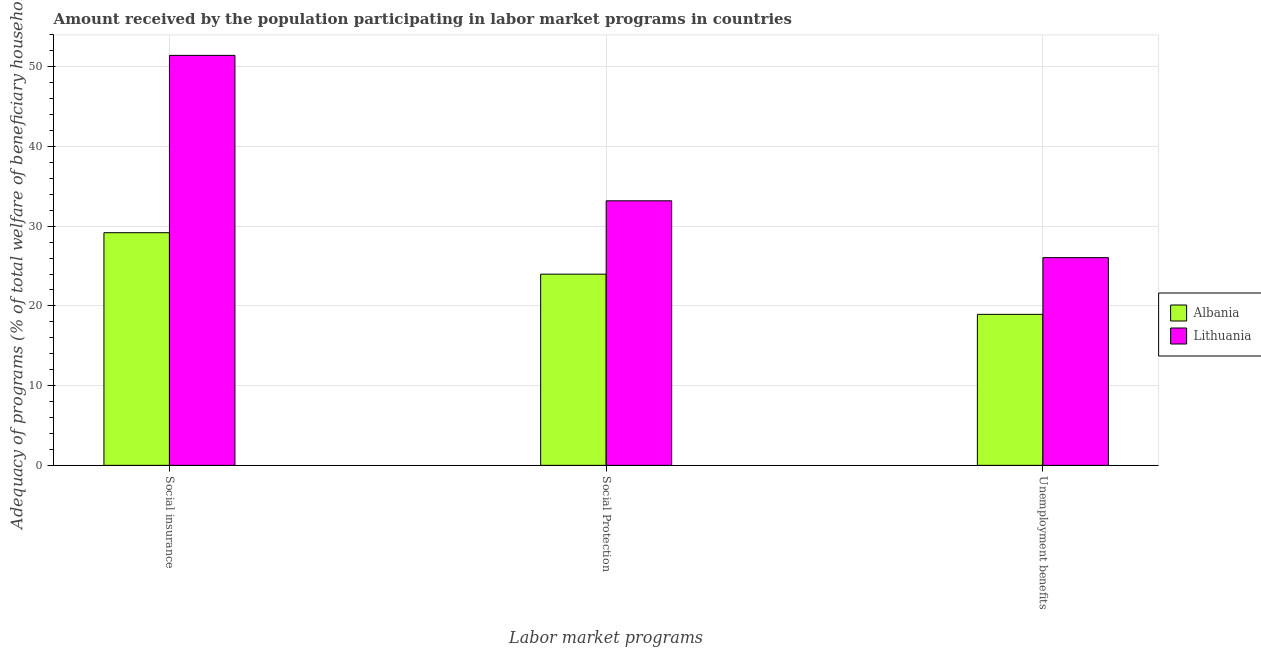Are the number of bars on each tick of the X-axis equal?
Your answer should be compact. Yes. What is the label of the 3rd group of bars from the left?
Make the answer very short. Unemployment benefits. What is the amount received by the population participating in unemployment benefits programs in Lithuania?
Provide a succinct answer. 26.06. Across all countries, what is the maximum amount received by the population participating in unemployment benefits programs?
Your answer should be very brief. 26.06. Across all countries, what is the minimum amount received by the population participating in social insurance programs?
Your response must be concise. 29.19. In which country was the amount received by the population participating in social protection programs maximum?
Keep it short and to the point. Lithuania. In which country was the amount received by the population participating in social protection programs minimum?
Keep it short and to the point. Albania. What is the total amount received by the population participating in unemployment benefits programs in the graph?
Offer a very short reply. 45. What is the difference between the amount received by the population participating in social insurance programs in Albania and that in Lithuania?
Provide a succinct answer. -22.25. What is the difference between the amount received by the population participating in social insurance programs in Lithuania and the amount received by the population participating in unemployment benefits programs in Albania?
Give a very brief answer. 32.49. What is the average amount received by the population participating in social protection programs per country?
Your answer should be very brief. 28.59. What is the difference between the amount received by the population participating in social protection programs and amount received by the population participating in unemployment benefits programs in Lithuania?
Keep it short and to the point. 7.13. In how many countries, is the amount received by the population participating in unemployment benefits programs greater than 44 %?
Your answer should be very brief. 0. What is the ratio of the amount received by the population participating in unemployment benefits programs in Albania to that in Lithuania?
Your answer should be compact. 0.73. What is the difference between the highest and the second highest amount received by the population participating in social insurance programs?
Keep it short and to the point. 22.25. What is the difference between the highest and the lowest amount received by the population participating in social insurance programs?
Ensure brevity in your answer.  22.25. What does the 2nd bar from the left in Unemployment benefits represents?
Keep it short and to the point. Lithuania. What does the 2nd bar from the right in Unemployment benefits represents?
Provide a succinct answer. Albania. Is it the case that in every country, the sum of the amount received by the population participating in social insurance programs and amount received by the population participating in social protection programs is greater than the amount received by the population participating in unemployment benefits programs?
Your answer should be compact. Yes. How many bars are there?
Provide a short and direct response. 6. Are all the bars in the graph horizontal?
Keep it short and to the point. No. Are the values on the major ticks of Y-axis written in scientific E-notation?
Your answer should be very brief. No. Does the graph contain any zero values?
Offer a terse response. No. Does the graph contain grids?
Ensure brevity in your answer.  Yes. Where does the legend appear in the graph?
Your answer should be compact. Center right. How many legend labels are there?
Offer a very short reply. 2. How are the legend labels stacked?
Ensure brevity in your answer.  Vertical. What is the title of the graph?
Ensure brevity in your answer.  Amount received by the population participating in labor market programs in countries. Does "Hong Kong" appear as one of the legend labels in the graph?
Provide a short and direct response. No. What is the label or title of the X-axis?
Offer a very short reply. Labor market programs. What is the label or title of the Y-axis?
Make the answer very short. Adequacy of programs (% of total welfare of beneficiary households). What is the Adequacy of programs (% of total welfare of beneficiary households) of Albania in Social insurance?
Provide a succinct answer. 29.19. What is the Adequacy of programs (% of total welfare of beneficiary households) in Lithuania in Social insurance?
Your answer should be compact. 51.43. What is the Adequacy of programs (% of total welfare of beneficiary households) in Albania in Social Protection?
Make the answer very short. 23.99. What is the Adequacy of programs (% of total welfare of beneficiary households) of Lithuania in Social Protection?
Provide a succinct answer. 33.19. What is the Adequacy of programs (% of total welfare of beneficiary households) of Albania in Unemployment benefits?
Keep it short and to the point. 18.94. What is the Adequacy of programs (% of total welfare of beneficiary households) of Lithuania in Unemployment benefits?
Keep it short and to the point. 26.06. Across all Labor market programs, what is the maximum Adequacy of programs (% of total welfare of beneficiary households) of Albania?
Ensure brevity in your answer.  29.19. Across all Labor market programs, what is the maximum Adequacy of programs (% of total welfare of beneficiary households) of Lithuania?
Your answer should be compact. 51.43. Across all Labor market programs, what is the minimum Adequacy of programs (% of total welfare of beneficiary households) in Albania?
Your answer should be compact. 18.94. Across all Labor market programs, what is the minimum Adequacy of programs (% of total welfare of beneficiary households) of Lithuania?
Your answer should be compact. 26.06. What is the total Adequacy of programs (% of total welfare of beneficiary households) of Albania in the graph?
Your response must be concise. 72.11. What is the total Adequacy of programs (% of total welfare of beneficiary households) in Lithuania in the graph?
Keep it short and to the point. 110.68. What is the difference between the Adequacy of programs (% of total welfare of beneficiary households) of Albania in Social insurance and that in Social Protection?
Offer a terse response. 5.2. What is the difference between the Adequacy of programs (% of total welfare of beneficiary households) of Lithuania in Social insurance and that in Social Protection?
Offer a terse response. 18.24. What is the difference between the Adequacy of programs (% of total welfare of beneficiary households) in Albania in Social insurance and that in Unemployment benefits?
Give a very brief answer. 10.24. What is the difference between the Adequacy of programs (% of total welfare of beneficiary households) of Lithuania in Social insurance and that in Unemployment benefits?
Provide a succinct answer. 25.37. What is the difference between the Adequacy of programs (% of total welfare of beneficiary households) of Albania in Social Protection and that in Unemployment benefits?
Provide a succinct answer. 5.04. What is the difference between the Adequacy of programs (% of total welfare of beneficiary households) of Lithuania in Social Protection and that in Unemployment benefits?
Ensure brevity in your answer.  7.13. What is the difference between the Adequacy of programs (% of total welfare of beneficiary households) in Albania in Social insurance and the Adequacy of programs (% of total welfare of beneficiary households) in Lithuania in Social Protection?
Offer a terse response. -4. What is the difference between the Adequacy of programs (% of total welfare of beneficiary households) of Albania in Social insurance and the Adequacy of programs (% of total welfare of beneficiary households) of Lithuania in Unemployment benefits?
Your answer should be very brief. 3.13. What is the difference between the Adequacy of programs (% of total welfare of beneficiary households) of Albania in Social Protection and the Adequacy of programs (% of total welfare of beneficiary households) of Lithuania in Unemployment benefits?
Make the answer very short. -2.07. What is the average Adequacy of programs (% of total welfare of beneficiary households) of Albania per Labor market programs?
Offer a very short reply. 24.04. What is the average Adequacy of programs (% of total welfare of beneficiary households) in Lithuania per Labor market programs?
Give a very brief answer. 36.89. What is the difference between the Adequacy of programs (% of total welfare of beneficiary households) in Albania and Adequacy of programs (% of total welfare of beneficiary households) in Lithuania in Social insurance?
Your answer should be very brief. -22.25. What is the difference between the Adequacy of programs (% of total welfare of beneficiary households) in Albania and Adequacy of programs (% of total welfare of beneficiary households) in Lithuania in Social Protection?
Offer a very short reply. -9.2. What is the difference between the Adequacy of programs (% of total welfare of beneficiary households) in Albania and Adequacy of programs (% of total welfare of beneficiary households) in Lithuania in Unemployment benefits?
Ensure brevity in your answer.  -7.12. What is the ratio of the Adequacy of programs (% of total welfare of beneficiary households) in Albania in Social insurance to that in Social Protection?
Your answer should be very brief. 1.22. What is the ratio of the Adequacy of programs (% of total welfare of beneficiary households) of Lithuania in Social insurance to that in Social Protection?
Your answer should be very brief. 1.55. What is the ratio of the Adequacy of programs (% of total welfare of beneficiary households) of Albania in Social insurance to that in Unemployment benefits?
Your answer should be compact. 1.54. What is the ratio of the Adequacy of programs (% of total welfare of beneficiary households) in Lithuania in Social insurance to that in Unemployment benefits?
Keep it short and to the point. 1.97. What is the ratio of the Adequacy of programs (% of total welfare of beneficiary households) in Albania in Social Protection to that in Unemployment benefits?
Your answer should be compact. 1.27. What is the ratio of the Adequacy of programs (% of total welfare of beneficiary households) of Lithuania in Social Protection to that in Unemployment benefits?
Ensure brevity in your answer.  1.27. What is the difference between the highest and the second highest Adequacy of programs (% of total welfare of beneficiary households) in Albania?
Ensure brevity in your answer.  5.2. What is the difference between the highest and the second highest Adequacy of programs (% of total welfare of beneficiary households) of Lithuania?
Provide a short and direct response. 18.24. What is the difference between the highest and the lowest Adequacy of programs (% of total welfare of beneficiary households) in Albania?
Provide a short and direct response. 10.24. What is the difference between the highest and the lowest Adequacy of programs (% of total welfare of beneficiary households) in Lithuania?
Provide a succinct answer. 25.37. 